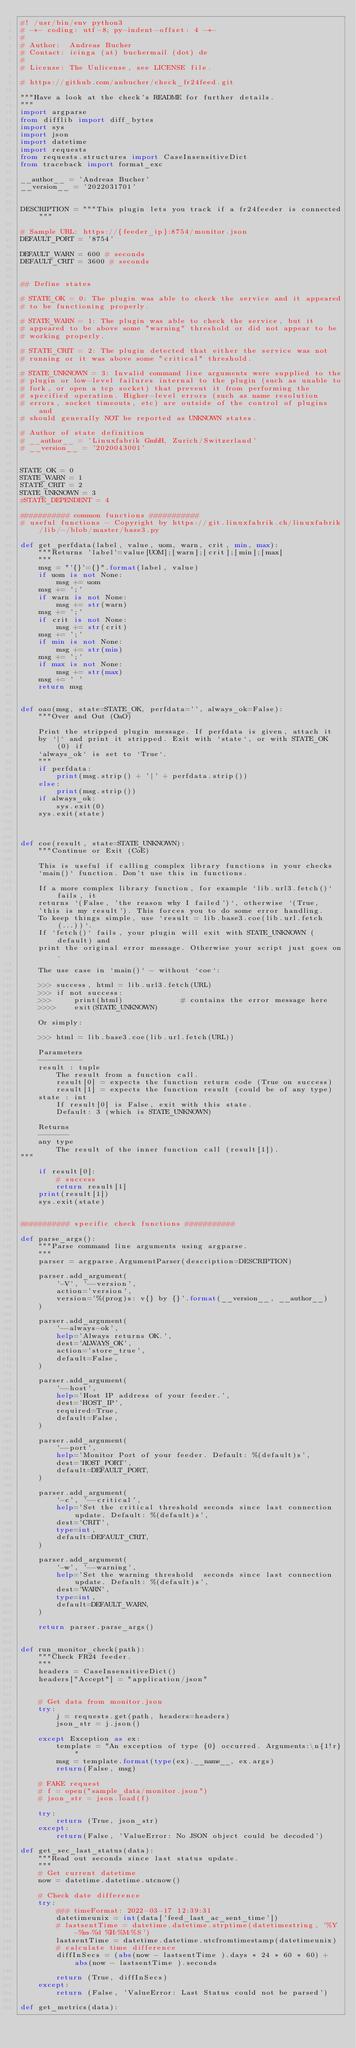Convert code to text. <code><loc_0><loc_0><loc_500><loc_500><_Python_>#! /usr/bin/env python3
# -*- coding: utf-8; py-indent-offset: 4 -*-
#
# Author:  Andreas Bucher
# Contact: icinga (at) buchermail (dot) de
#          
# License: The Unlicense, see LICENSE file.

# https://github.com/anbucher/check_fr24feed.git

"""Have a look at the check's README for further details.
"""
import argparse
from difflib import diff_bytes
import sys
import json
import datetime
import requests
from requests.structures import CaseInsensitiveDict
from traceback import format_exc

__author__ = 'Andreas Bucher'
__version__ = '2022031701'


DESCRIPTION = """This plugin lets you track if a fr24feeder is connected"""

# Sample URL: https://{feeder_ip}:8754/monitor.json
DEFAULT_PORT = '8754'

DEFAULT_WARN = 600 # seconds
DEFAULT_CRIT = 3600 # seconds


## Define states

# STATE_OK = 0: The plugin was able to check the service and it appeared
# to be functioning properly.

# STATE_WARN = 1: The plugin was able to check the service, but it
# appeared to be above some "warning" threshold or did not appear to be
# working properly.

# STATE_CRIT = 2: The plugin detected that either the service was not
# running or it was above some "critical" threshold.

# STATE_UNKNOWN = 3: Invalid command line arguments were supplied to the
# plugin or low-level failures internal to the plugin (such as unable to
# fork, or open a tcp socket) that prevent it from performing the
# specified operation. Higher-level errors (such as name resolution
# errors, socket timeouts, etc) are outside of the control of plugins and
# should generally NOT be reported as UNKNOWN states.

# Author of state definition
# __author__ = 'Linuxfabrik GmbH, Zurich/Switzerland'
# __version__ = '2020043001'


STATE_OK = 0
STATE_WARN = 1
STATE_CRIT = 2
STATE_UNKNOWN = 3
#STATE_DEPENDENT = 4

########### common functions ###########
# useful functions - Copyright by https://git.linuxfabrik.ch/linuxfabrik/lib/-/blob/master/base3.py

def get_perfdata(label, value, uom, warn, crit, min, max):
    """Returns 'label'=value[UOM];[warn];[crit];[min];[max]
    """
    msg = "'{}'={}".format(label, value)
    if uom is not None:
        msg += uom
    msg += ';'
    if warn is not None:
        msg += str(warn)
    msg += ';'
    if crit is not None:
        msg += str(crit)
    msg += ';'
    if min is not None:
        msg += str(min)
    msg += ';'
    if max is not None:
        msg += str(max)
    msg += ' '
    return msg


def oao(msg, state=STATE_OK, perfdata='', always_ok=False):
    """Over and Out (OaO)

    Print the stripped plugin message. If perfdata is given, attach it
    by `|` and print it stripped. Exit with `state`, or with STATE_OK (0) if
    `always_ok` is set to `True`.
    """
    if perfdata:
        print(msg.strip() + '|' + perfdata.strip())
    else:
        print(msg.strip())
    if always_ok:
        sys.exit(0)
    sys.exit(state)



def coe(result, state=STATE_UNKNOWN):
    """Continue or Exit (CoE)

    This is useful if calling complex library functions in your checks
    `main()` function. Don't use this in functions.

    If a more complex library function, for example `lib.url3.fetch()` fails, it
    returns `(False, 'the reason why I failed')`, otherwise `(True,
    'this is my result'). This forces you to do some error handling.
    To keep things simple, use `result = lib.base3.coe(lib.url.fetch(...))`.
    If `fetch()` fails, your plugin will exit with STATE_UNKNOWN (default) and
    print the original error message. Otherwise your script just goes on.

    The use case in `main()` - without `coe`:

    >>> success, html = lib.url3.fetch(URL)
    >>> if not success:
    >>>     print(html)             # contains the error message here
    >>>>    exit(STATE_UNKNOWN)

    Or simply:

    >>> html = lib.base3.coe(lib.url.fetch(URL))

    Parameters
    ----------
    result : tuple
        The result from a function call.
        result[0] = expects the function return code (True on success)
        result[1] = expects the function result (could be of any type)
    state : int
        If result[0] is False, exit with this state.
        Default: 3 (which is STATE_UNKNOWN)

    Returns
    -------
    any type
        The result of the inner function call (result[1]).
"""

    if result[0]:
        # success
        return result[1]
    print(result[1])
    sys.exit(state)


########### specific check functions ###########

def parse_args():
    """Parse command line arguments using argparse.
    """
    parser = argparse.ArgumentParser(description=DESCRIPTION)

    parser.add_argument(
        '-V', '--version',
        action='version',
        version='%(prog)s: v{} by {}'.format(__version__, __author__)
    )

    parser.add_argument(
        '--always-ok',
        help='Always returns OK.',
        dest='ALWAYS_OK',
        action='store_true',
        default=False,
    )

    parser.add_argument(
        '--host',
        help='Host IP address of your feeder.',
        dest='HOST_IP',
        required=True,
        default=False,
    )

    parser.add_argument(
        '--port',
        help='Monitor Port of your feeder. Default: %(default)s',
        dest='HOST_PORT',
        default=DEFAULT_PORT,
    )

    parser.add_argument(
        '-c', '--critical',
        help='Set the critical threshold seconds since last connection update. Default: %(default)s',
        dest='CRIT',
        type=int,
        default=DEFAULT_CRIT,
    )

    parser.add_argument(
        '-w', '--warning',
        help='Set the warning threshold  seconds since last connection update. Default: %(default)s',
        dest='WARN',
        type=int,
        default=DEFAULT_WARN,
    )

    return parser.parse_args()


def run_monitor_check(path):
    """Check FR24 feeder.
    """
    headers = CaseInsensitiveDict()
    headers["Accept"] = "application/json"


    # Get data from monitor.json
    try:
        j = requests.get(path, headers=headers)
        json_str = j.json()

    except Exception as ex:
        template = "An exception of type {0} occurred. Arguments:\n{1!r}"
        msg = template.format(type(ex).__name__, ex.args)
        return(False, msg)

    # FAKE request
    # f = open("sample_data/monitor.json")
    # json_str = json.load(f)

    try:
        return (True, json_str)
    except:
        return(False, 'ValueError: No JSON object could be decoded')

def get_sec_last_status(data):
    """Read out seconds since last status update.
    """
    # Get current datetime
    now = datetime.datetime.utcnow()

    # Check date difference
    try:
        ### timeFormat: 2022-03-17 12:39:31
        datetimeunix = int(data['feed_last_ac_sent_time'])
        # lastsentTime = datetime.datetime.strptime(datetimestring, '%Y-%m-%d %H:%M:%S')
        lastsentTime = datetime.datetime.utcfromtimestamp(datetimeunix)
        # calculate time difference
        diffInSecs = (abs(now - lastsentTime ).days * 24 * 60 * 60) + abs(now - lastsentTime ).seconds

        return (True, diffInSecs)
    except:
        return (False, 'ValueError: Last Status could not be parsed') 

def get_metrics(data):
</code> 